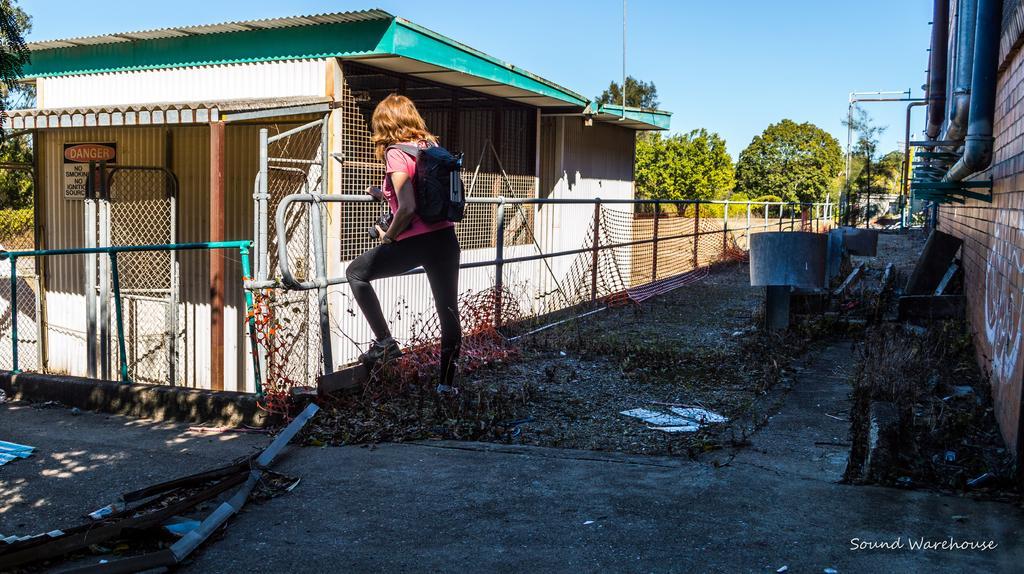In one or two sentences, can you explain what this image depicts? In this image there is one women standing in middle of this image and holding a backpack,and there is a fencing wall in middle of this image, and there is a house on the left side of this image. There are some trees in the background. There is a sky on the top of this image. There is a wall on the right side of this image and there are some pipes attached on it. There is a ground in the bottom of this image. 